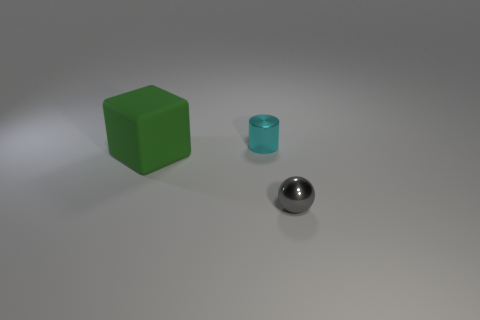What number of things are small things or small blue matte balls?
Keep it short and to the point. 2. How many objects are gray things or small things that are behind the large cube?
Your response must be concise. 2. Do the tiny cyan object and the gray thing have the same material?
Offer a terse response. Yes. How many other things are made of the same material as the ball?
Keep it short and to the point. 1. Are there more tiny green metallic cubes than spheres?
Your answer should be compact. No. Does the small shiny object in front of the large green matte block have the same shape as the cyan object?
Your response must be concise. No. Is the number of big green things less than the number of tiny brown matte things?
Your answer should be very brief. No. There is a cyan object that is the same size as the gray metallic ball; what material is it?
Provide a succinct answer. Metal. Is the color of the tiny shiny cylinder the same as the metal object that is in front of the cube?
Ensure brevity in your answer.  No. Is the number of tiny gray metal objects behind the green cube less than the number of green balls?
Your response must be concise. No. 